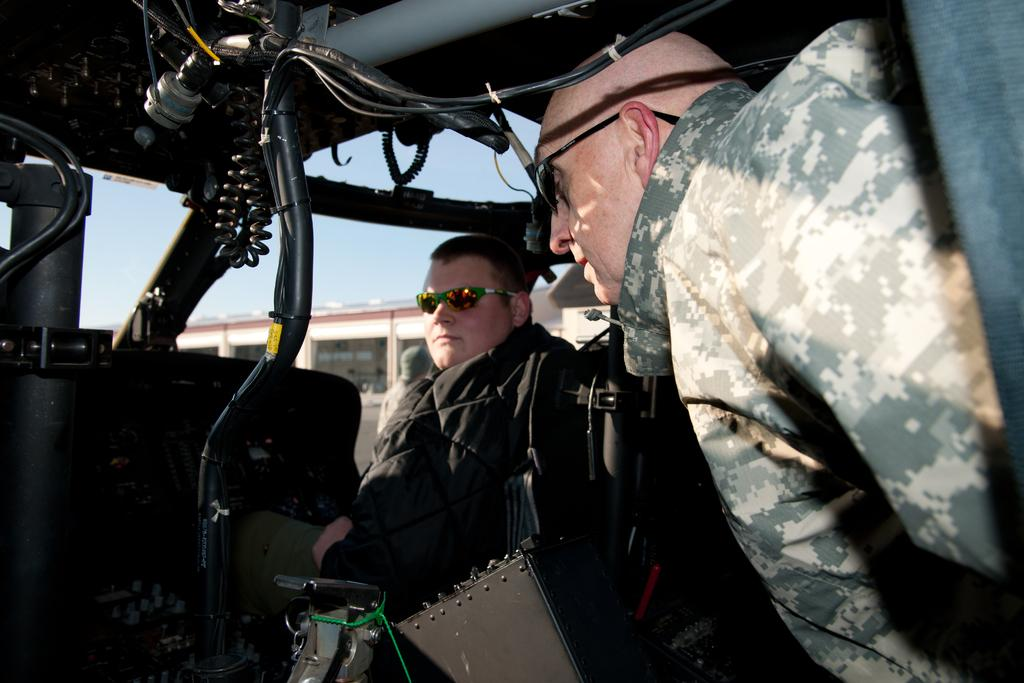How many people are inside the vehicle in the image? There are two persons sitting inside the vehicle. What is connected to the vehicle in the image? The vehicle has cables attached to it. What can be seen in the background of the image? There is a building and the sky visible in the background of the image. What type of coil is being used by the persons inside the vehicle in the image? There is no coil visible in the image; the vehicle has cables attached to it, but they are not described as coils. 